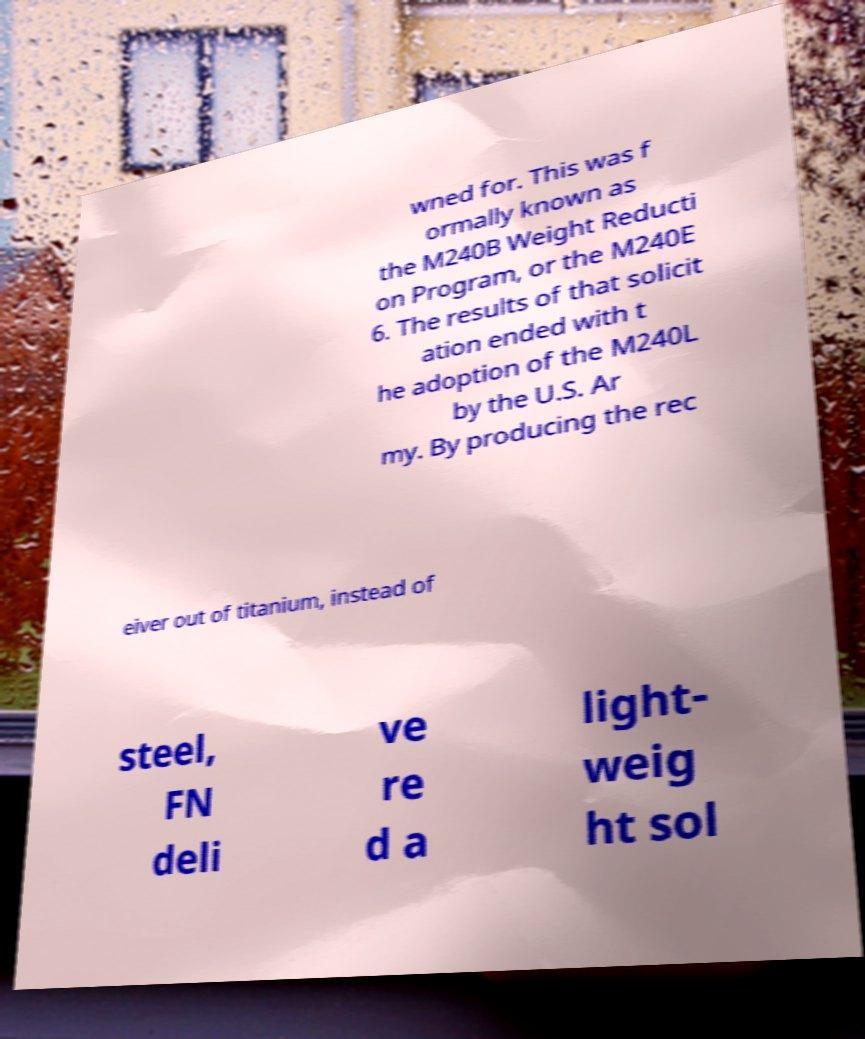What messages or text are displayed in this image? I need them in a readable, typed format. wned for. This was f ormally known as the M240B Weight Reducti on Program, or the M240E 6. The results of that solicit ation ended with t he adoption of the M240L by the U.S. Ar my. By producing the rec eiver out of titanium, instead of steel, FN deli ve re d a light- weig ht sol 